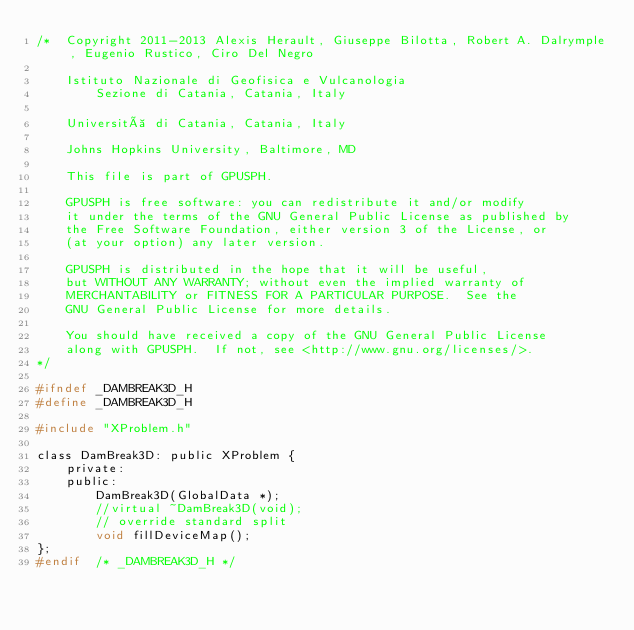<code> <loc_0><loc_0><loc_500><loc_500><_C_>/*  Copyright 2011-2013 Alexis Herault, Giuseppe Bilotta, Robert A. Dalrymple, Eugenio Rustico, Ciro Del Negro

    Istituto Nazionale di Geofisica e Vulcanologia
        Sezione di Catania, Catania, Italy

    Università di Catania, Catania, Italy

    Johns Hopkins University, Baltimore, MD

    This file is part of GPUSPH.

    GPUSPH is free software: you can redistribute it and/or modify
    it under the terms of the GNU General Public License as published by
    the Free Software Foundation, either version 3 of the License, or
    (at your option) any later version.

    GPUSPH is distributed in the hope that it will be useful,
    but WITHOUT ANY WARRANTY; without even the implied warranty of
    MERCHANTABILITY or FITNESS FOR A PARTICULAR PURPOSE.  See the
    GNU General Public License for more details.

    You should have received a copy of the GNU General Public License
    along with GPUSPH.  If not, see <http://www.gnu.org/licenses/>.
*/

#ifndef _DAMBREAK3D_H
#define	_DAMBREAK3D_H

#include "XProblem.h"

class DamBreak3D: public XProblem {
	private:
	public:
		DamBreak3D(GlobalData *);
		//virtual ~DamBreak3D(void);
		// override standard split
		void fillDeviceMap();
};
#endif	/* _DAMBREAK3D_H */

</code> 